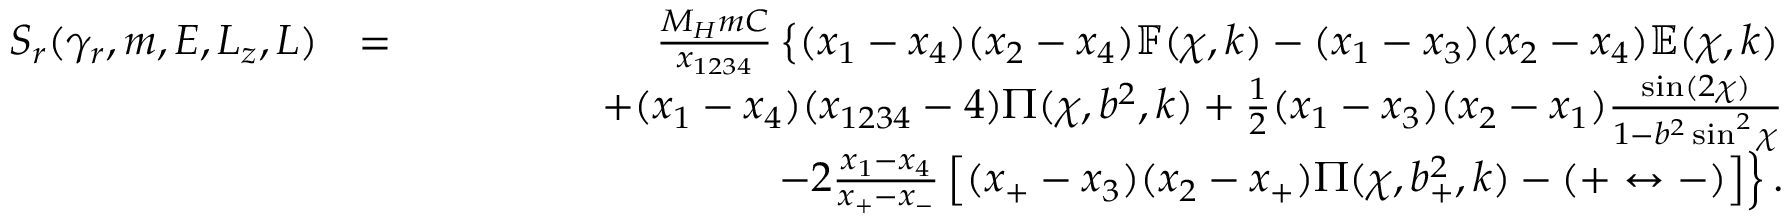Convert formula to latex. <formula><loc_0><loc_0><loc_500><loc_500>\begin{array} { r l r } { S _ { r } ( \gamma _ { r } , m , E , L _ { z } , L ) } & { = } & { \frac { M _ { H } m C } { x _ { 1 2 3 4 } } \left \{ ( x _ { 1 } - x _ { 4 } ) ( x _ { 2 } - x _ { 4 } ) \mathbb { F } ( \chi , k ) - ( x _ { 1 } - x _ { 3 } ) ( x _ { 2 } - x _ { 4 } ) \mathbb { E } ( \chi , k ) } \\ & { \quad + ( x _ { 1 } - x _ { 4 } ) ( x _ { 1 2 3 4 } - 4 ) \Pi ( \chi , b ^ { 2 } , k ) + \frac { 1 } { 2 } ( x _ { 1 } - x _ { 3 } ) ( x _ { 2 } - x _ { 1 } ) \frac { \sin ( 2 \chi ) } { 1 - b ^ { 2 } \sin ^ { 2 } \chi } } \\ & { \quad - 2 \frac { x _ { 1 } - x _ { 4 } } { x _ { + } - x _ { - } } \left [ ( x _ { + } - x _ { 3 } ) ( x _ { 2 } - x _ { + } ) \Pi ( \chi , b _ { + } ^ { 2 } , k ) - ( + \leftrightarrow - ) \right ] \right \} . } \end{array}</formula> 